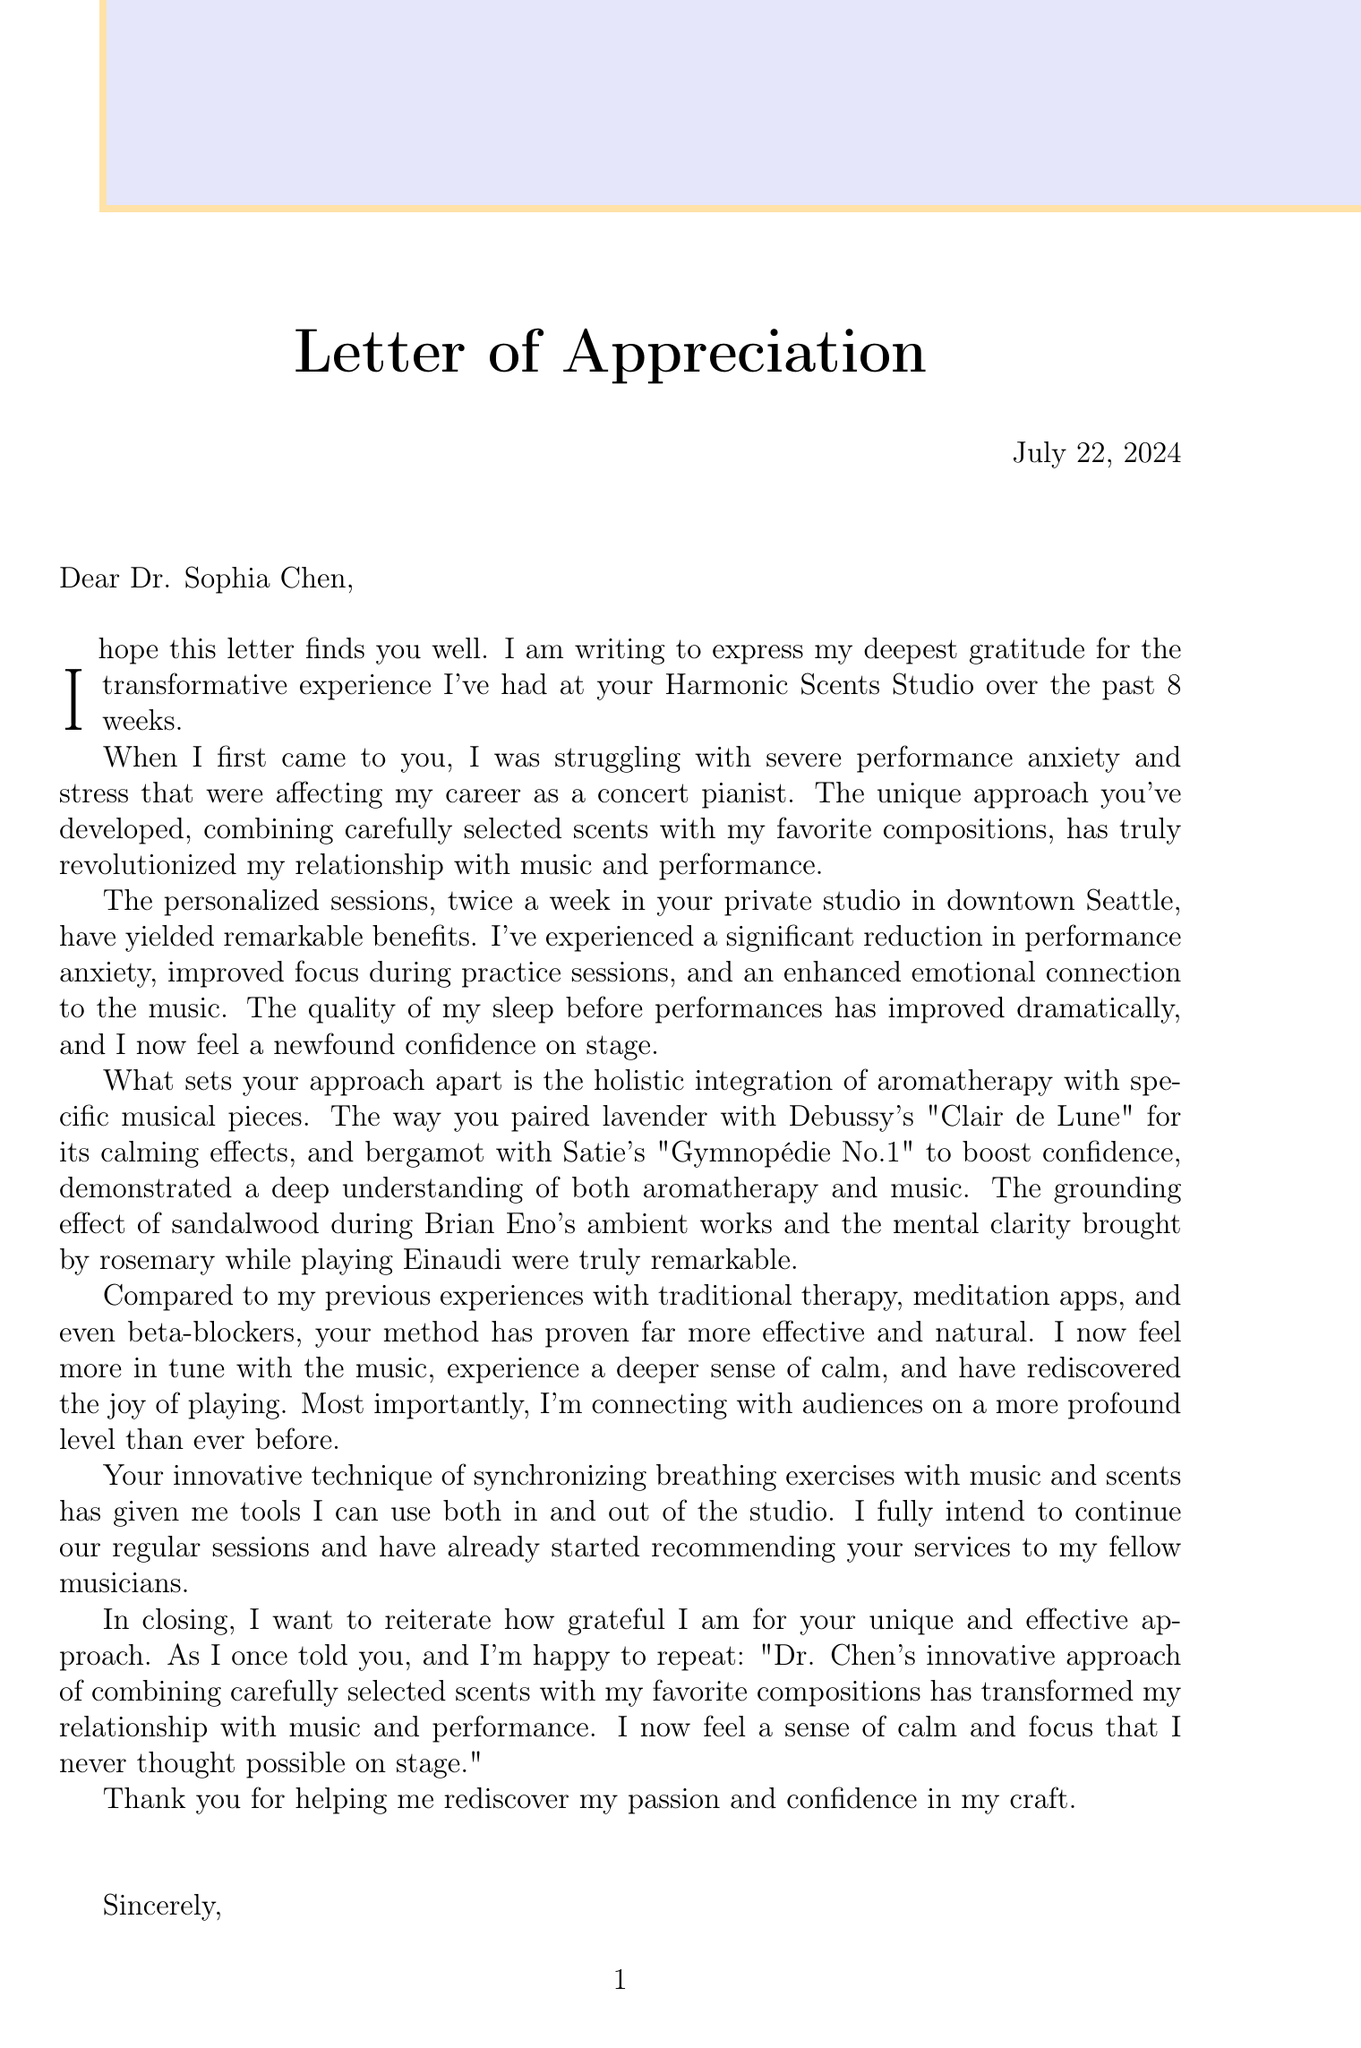What is the name of the client? The client's name is stated explicitly in the document as Emily Rowland.
Answer: Emily Rowland What is the main issue the client faced? The document highlights that the client's main issue was performance anxiety and stress.
Answer: Performance anxiety and stress How long did the sessions last? The duration of the sessions is mentioned in the document as 8 weeks.
Answer: 8 weeks How often did the client attend sessions? The document specifies that the client attended sessions twice a week.
Answer: Twice a week What unique approach does Dr. Sophia Chen integrate in her sessions? The document explains that Dr. Chen integrates aromatherapy with specific musical pieces as a unique approach.
Answer: Aromatherapy with specific musical pieces What significant benefit did the client experience related to sleep? It is noted in the document that the client experienced better sleep quality before performances.
Answer: Better sleep quality before performances Which scent was paired with Debussy's "Clair de Lune"? The document explicitly states that lavender was paired with Debussy's "Clair de Lune."
Answer: Lavender What future intentions does the client express regarding sessions? The client indicates the intention to continue regular sessions as stated in the document.
Answer: Continue regular sessions How did the client compare Dr. Chen's method to previous treatments? The client describes Dr. Chen's method as far more effective and natural compared to previous treatments mentioned in the document.
Answer: More effective and natural 